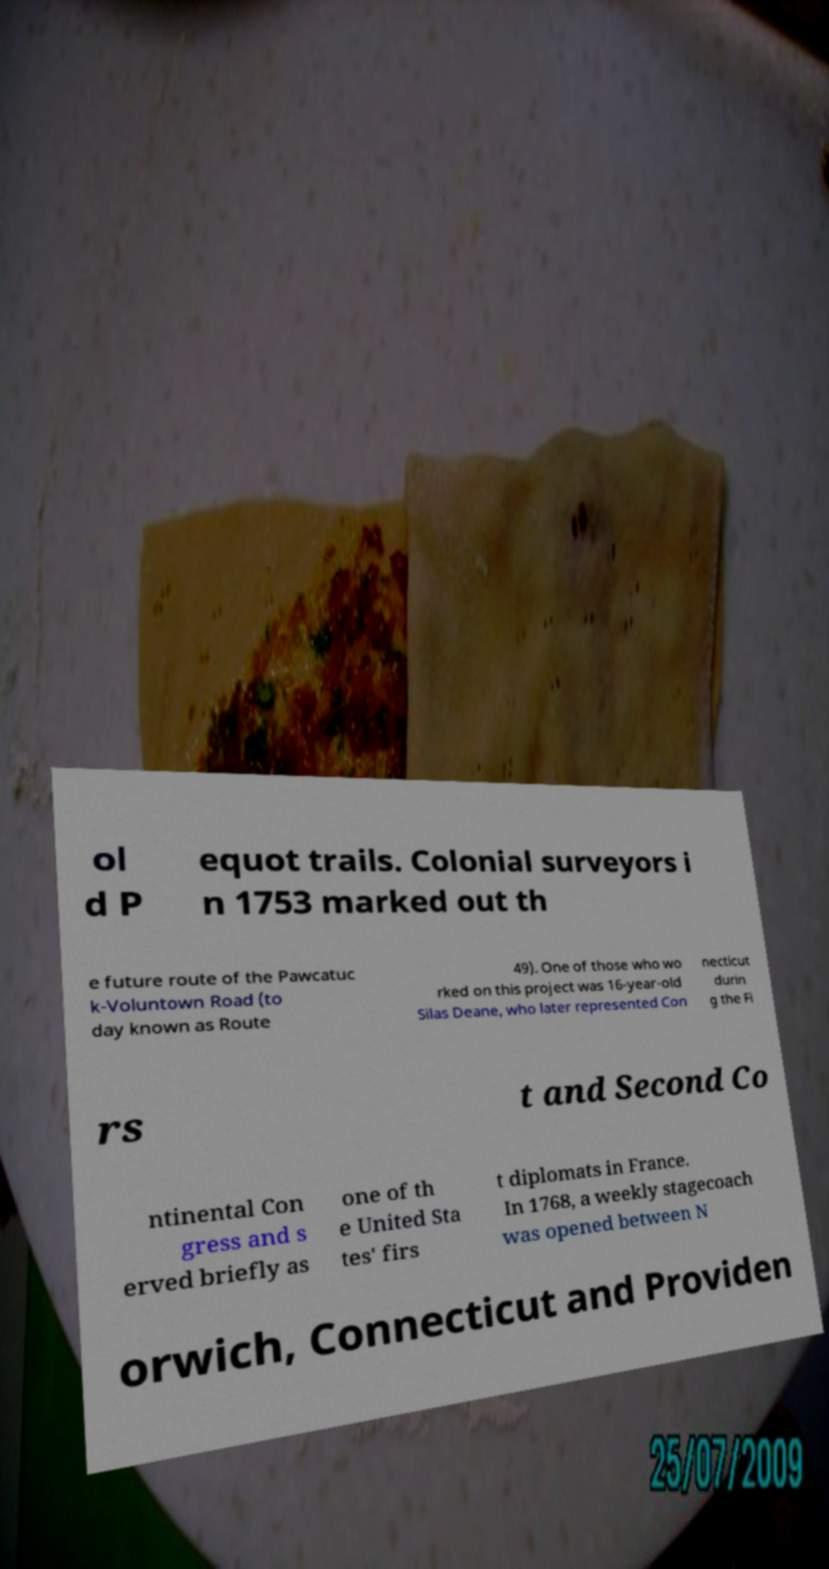What messages or text are displayed in this image? I need them in a readable, typed format. ol d P equot trails. Colonial surveyors i n 1753 marked out th e future route of the Pawcatuc k-Voluntown Road (to day known as Route 49). One of those who wo rked on this project was 16-year-old Silas Deane, who later represented Con necticut durin g the Fi rs t and Second Co ntinental Con gress and s erved briefly as one of th e United Sta tes' firs t diplomats in France. In 1768, a weekly stagecoach was opened between N orwich, Connecticut and Providen 